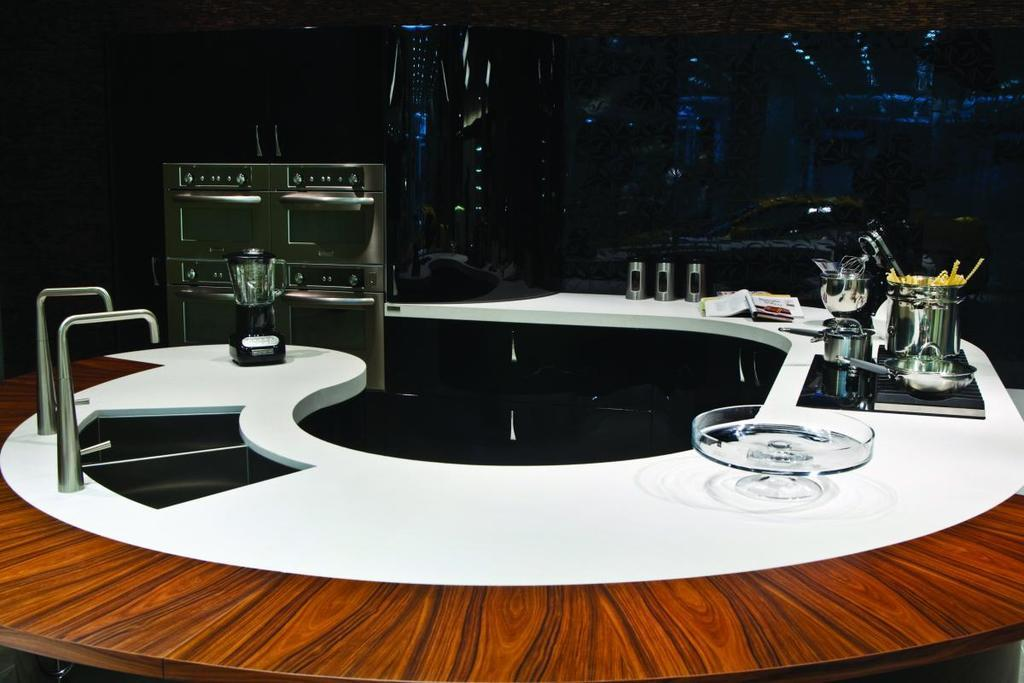What type of kitchen appliance is present in the image? There is a mixer in the image. What is the purpose of the stove with vessels in the image? The stove with vessels is used for cooking. What is the purpose of the wash basin in the image? The wash basin is likely used for washing hands or dishes. What type of kitchen appliance is used for heating food in the image? There is a microwave oven in the image, which is used for heating food. Can you see any corks floating in the wash basin in the image? There are no corks present in the image, as it features kitchen appliances and tools. 